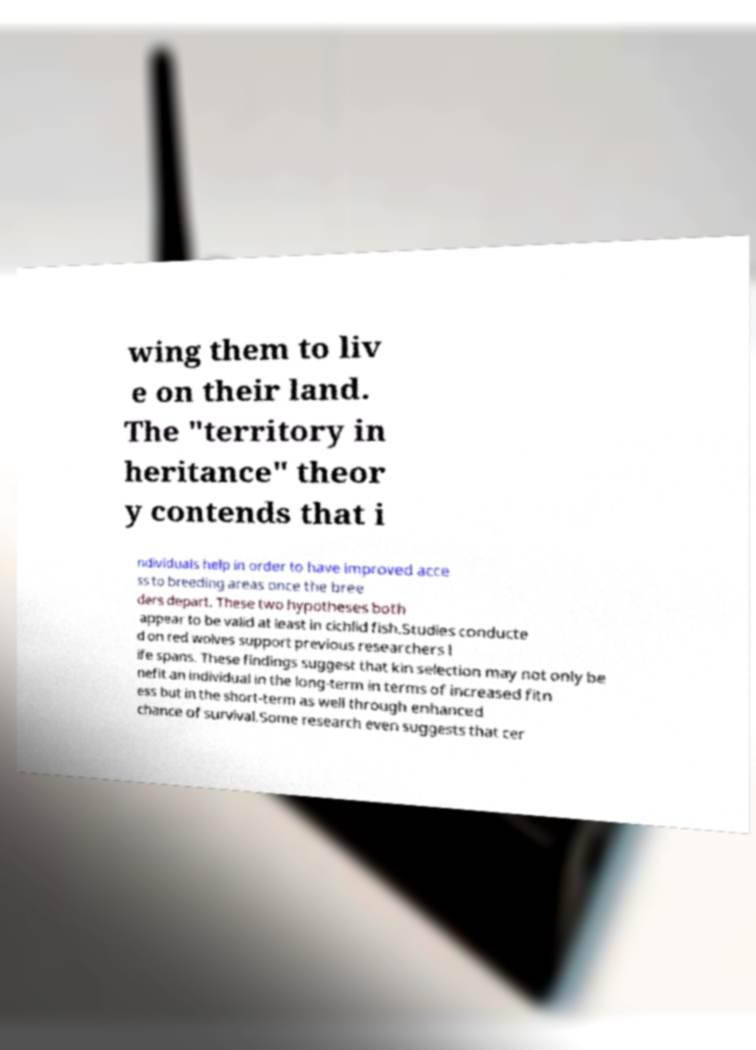Can you accurately transcribe the text from the provided image for me? wing them to liv e on their land. The "territory in heritance" theor y contends that i ndividuals help in order to have improved acce ss to breeding areas once the bree ders depart. These two hypotheses both appear to be valid at least in cichlid fish.Studies conducte d on red wolves support previous researchers l ife spans. These findings suggest that kin selection may not only be nefit an individual in the long-term in terms of increased fitn ess but in the short-term as well through enhanced chance of survival.Some research even suggests that cer 